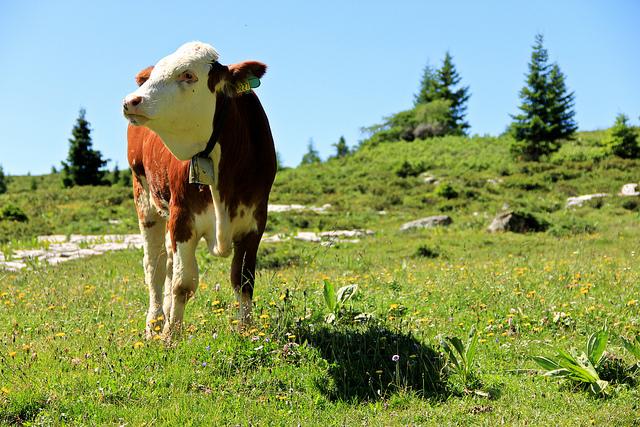What is around the cow's neck?
Write a very short answer. Bell. What is the cows name?
Quick response, please. Betsy. How can you tell this cow has an owner?
Be succinct. Bell. 